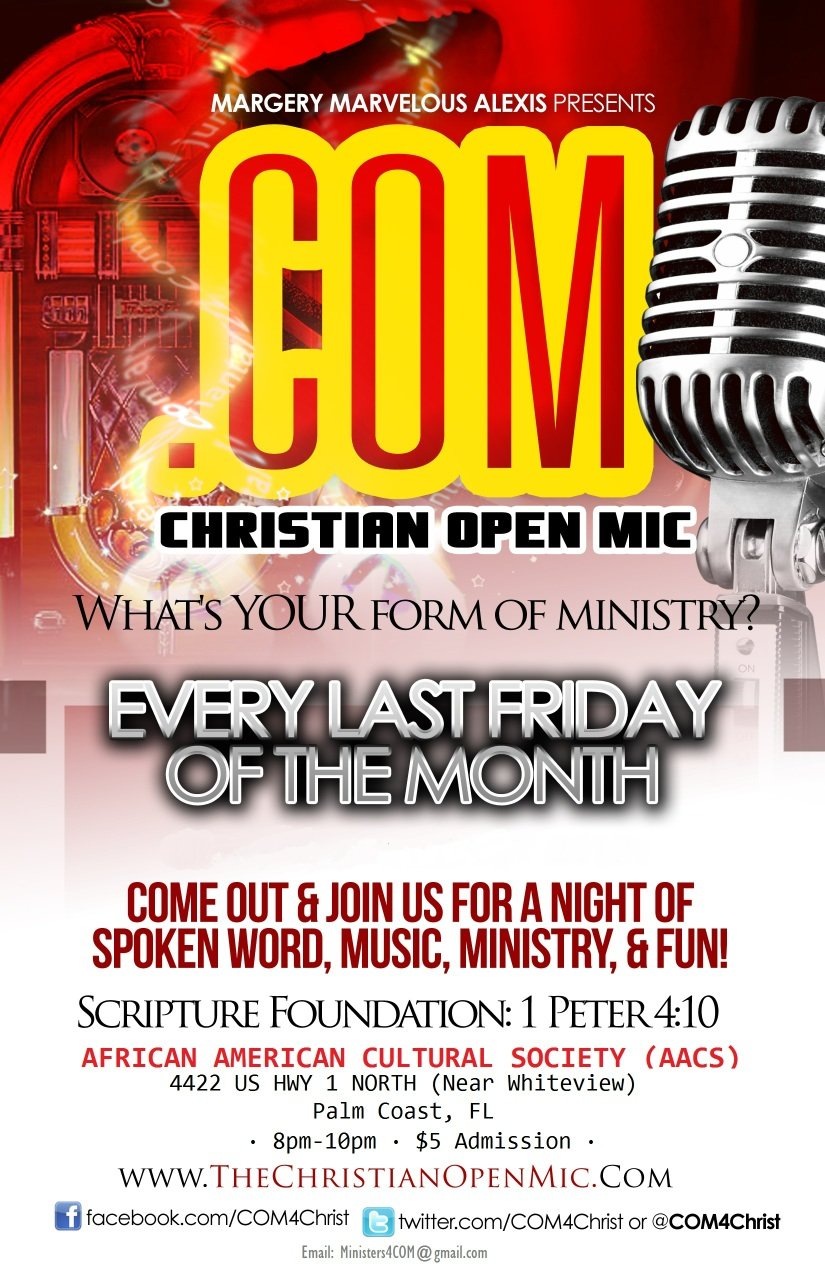How often does the Christian Open Mic event occur? The Christian Open Mic event takes place every last Friday of the month, offering a consistent opportunity for individuals to share their talents and express their faith through spoken word, music, and ministry. 